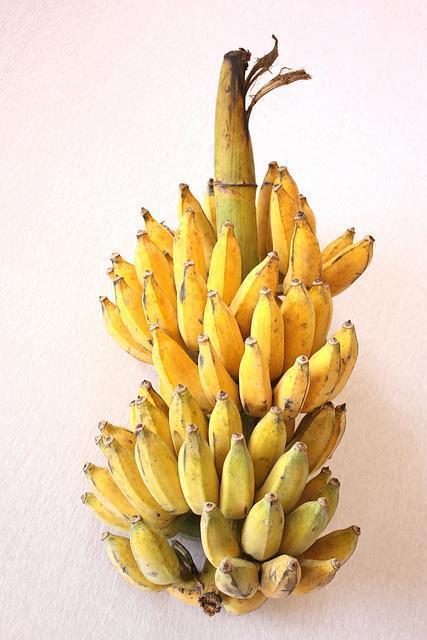How many different fruits do you see?
Give a very brief answer. 1. 